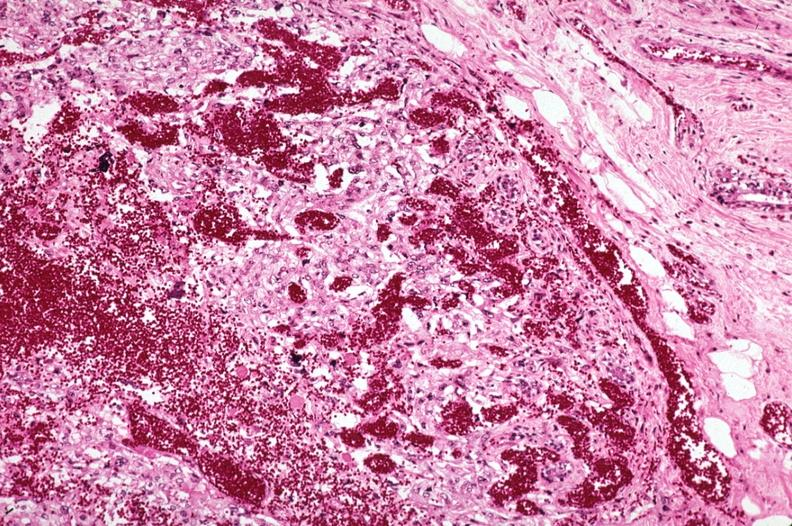what is present?
Answer the question using a single word or phrase. Metastatic carcinoma 